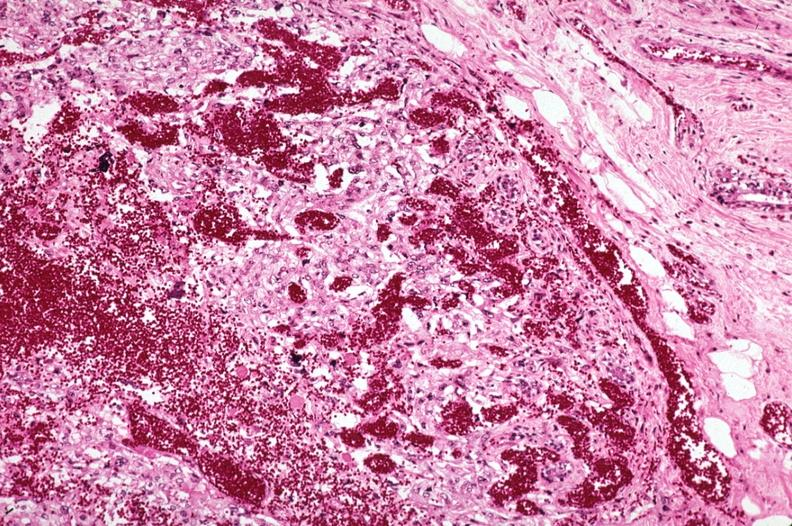what is present?
Answer the question using a single word or phrase. Metastatic carcinoma 